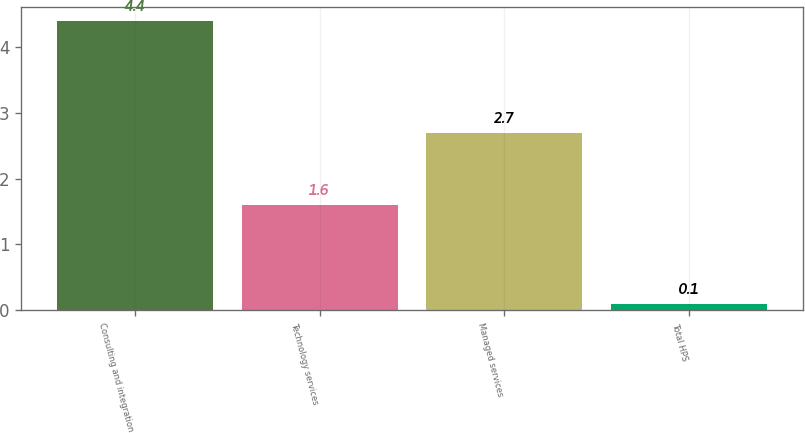<chart> <loc_0><loc_0><loc_500><loc_500><bar_chart><fcel>Consulting and integration<fcel>Technology services<fcel>Managed services<fcel>Total HPS<nl><fcel>4.4<fcel>1.6<fcel>2.7<fcel>0.1<nl></chart> 